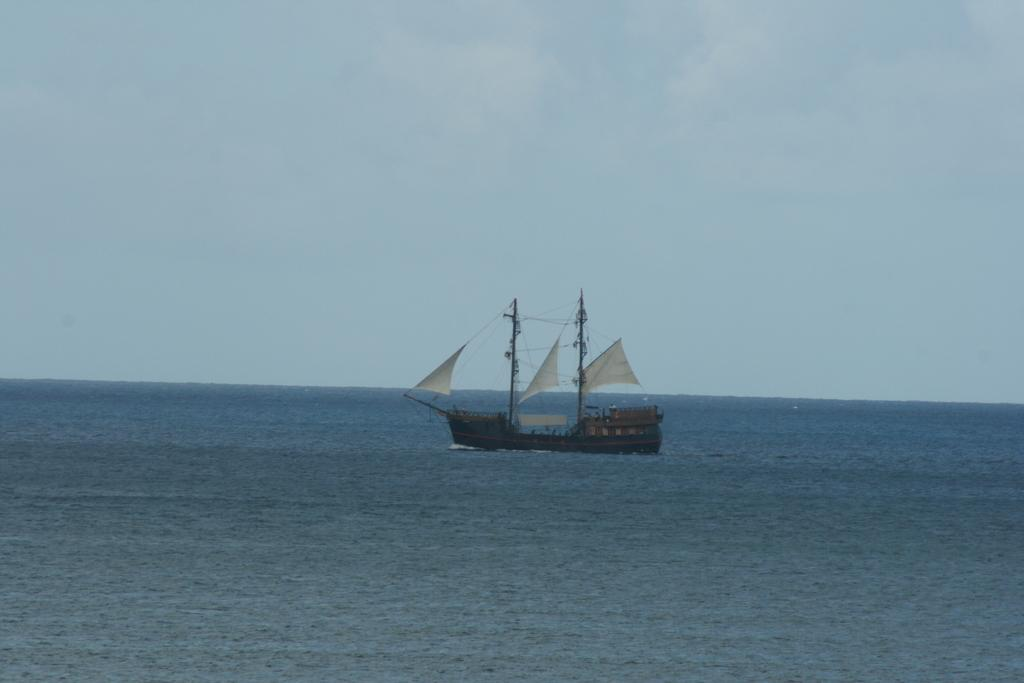What is the main subject of the image? The main subject of the image is a ship. Where is the ship located in the image? The ship is sailing in the ocean. What is the condition of the sky in the image? The sky is clear in the image. Can you tell me how many experts are on board the ship in the image? There is no information about experts on board the ship in the image, so we cannot determine their number. Is there a hook visible in the image? There is no hook present in the image. 